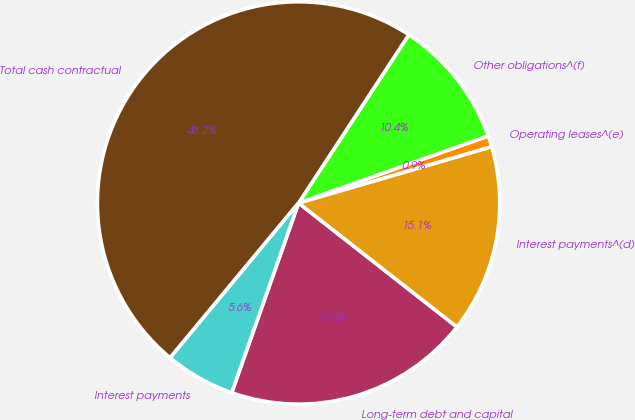Convert chart to OTSL. <chart><loc_0><loc_0><loc_500><loc_500><pie_chart><fcel>Long-term debt and capital<fcel>Interest payments^(d)<fcel>Operating leases^(e)<fcel>Other obligations^(f)<fcel>Total cash contractual<fcel>Interest payments<nl><fcel>19.82%<fcel>15.09%<fcel>0.89%<fcel>10.36%<fcel>48.21%<fcel>5.63%<nl></chart> 